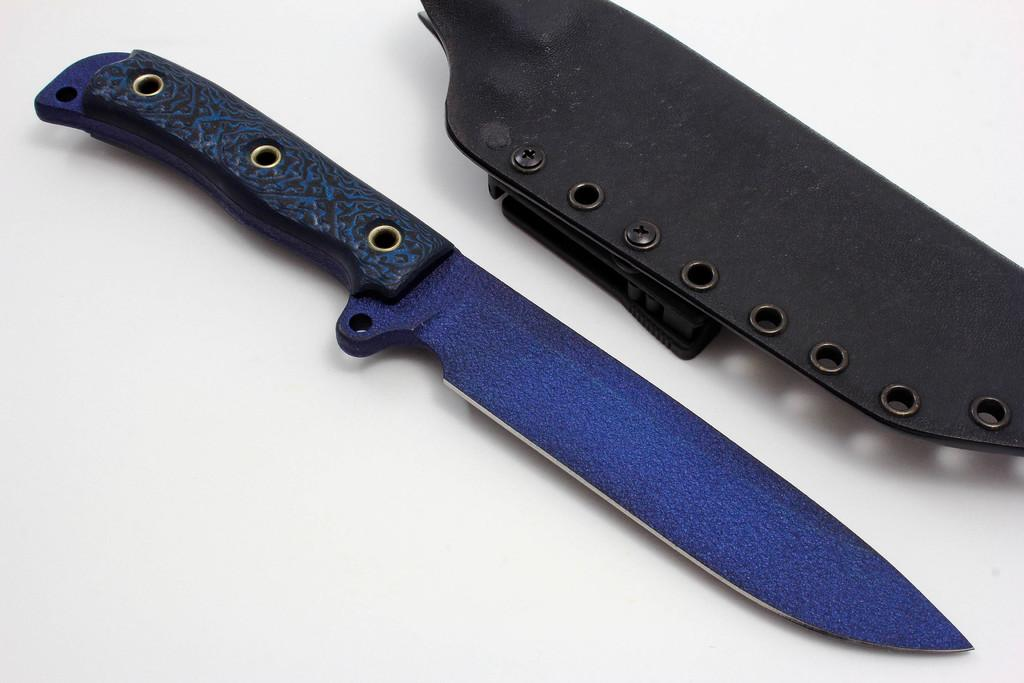What type of knife is in the image? There is a bowie knife in the image. Where is the bowie knife located? The bowie knife is placed on a surface. What type of hat is the porter wearing in the image? There is no porter or hat present in the image; it only features a bowie knife placed on a surface. 